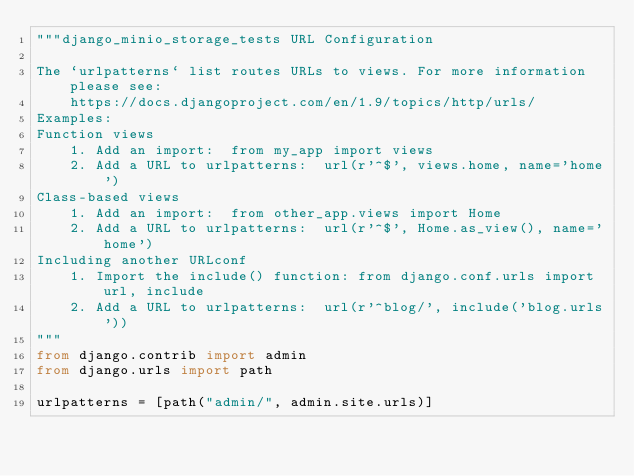Convert code to text. <code><loc_0><loc_0><loc_500><loc_500><_Python_>"""django_minio_storage_tests URL Configuration

The `urlpatterns` list routes URLs to views. For more information please see:
    https://docs.djangoproject.com/en/1.9/topics/http/urls/
Examples:
Function views
    1. Add an import:  from my_app import views
    2. Add a URL to urlpatterns:  url(r'^$', views.home, name='home')
Class-based views
    1. Add an import:  from other_app.views import Home
    2. Add a URL to urlpatterns:  url(r'^$', Home.as_view(), name='home')
Including another URLconf
    1. Import the include() function: from django.conf.urls import url, include
    2. Add a URL to urlpatterns:  url(r'^blog/', include('blog.urls'))
"""
from django.contrib import admin
from django.urls import path

urlpatterns = [path("admin/", admin.site.urls)]
</code> 